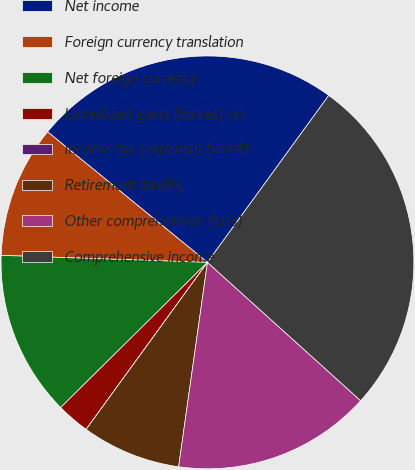Convert chart to OTSL. <chart><loc_0><loc_0><loc_500><loc_500><pie_chart><fcel>Net income<fcel>Foreign currency translation<fcel>Net foreign currency<fcel>Unrealized gains (losses) on<fcel>Income tax (expense) benefit<fcel>Retirement liability<fcel>Other comprehensive (loss)<fcel>Comprehensive income<nl><fcel>24.1%<fcel>10.36%<fcel>12.95%<fcel>2.59%<fcel>0.0%<fcel>7.77%<fcel>15.54%<fcel>26.69%<nl></chart> 